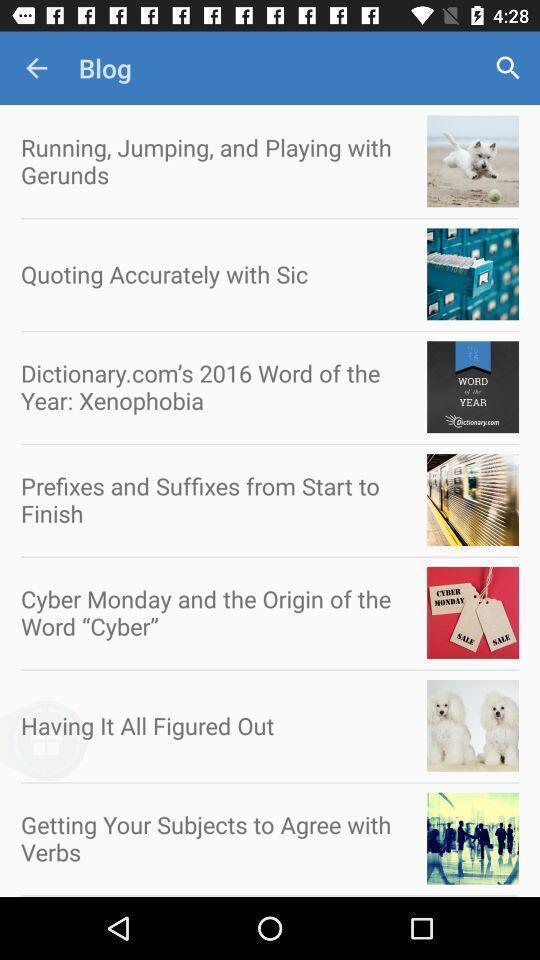Explain the elements present in this screenshot. Page displaying various articles. 